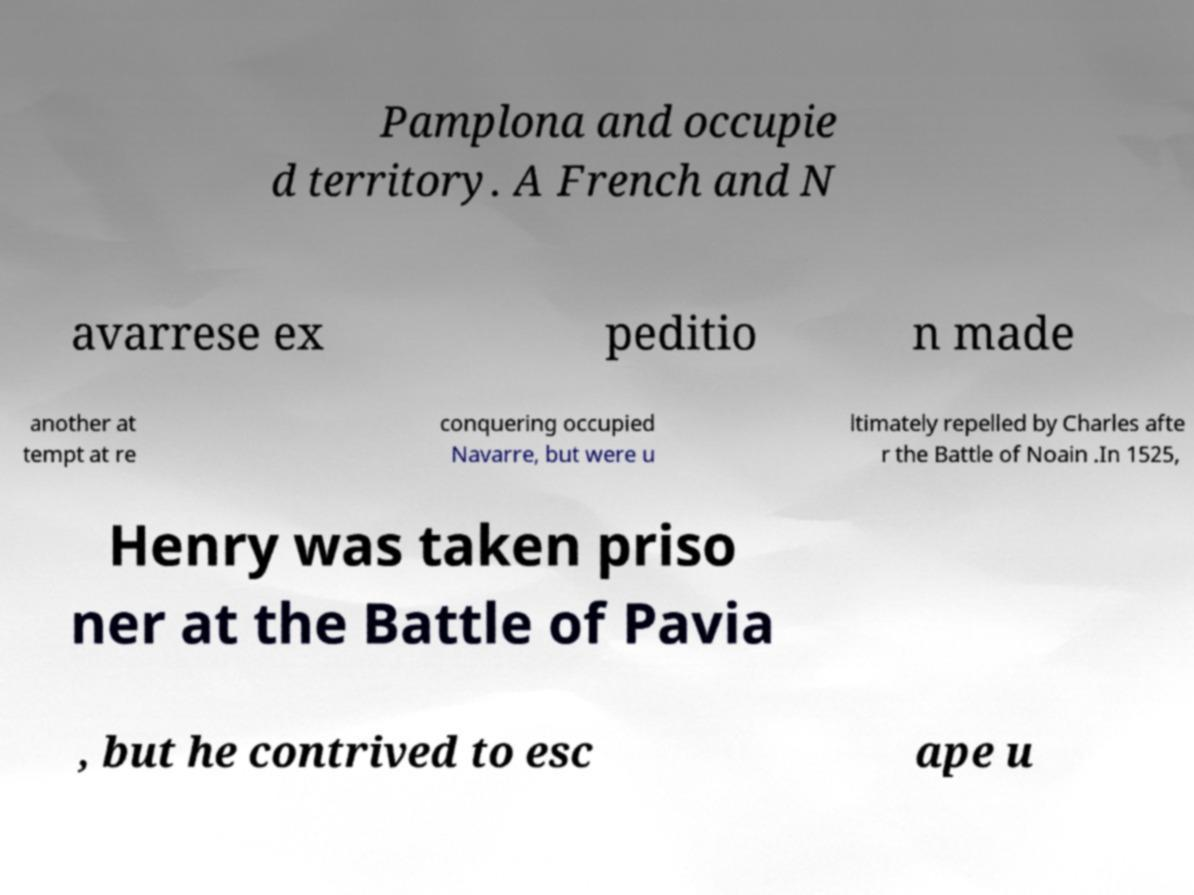Please read and relay the text visible in this image. What does it say? Pamplona and occupie d territory. A French and N avarrese ex peditio n made another at tempt at re conquering occupied Navarre, but were u ltimately repelled by Charles afte r the Battle of Noain .In 1525, Henry was taken priso ner at the Battle of Pavia , but he contrived to esc ape u 